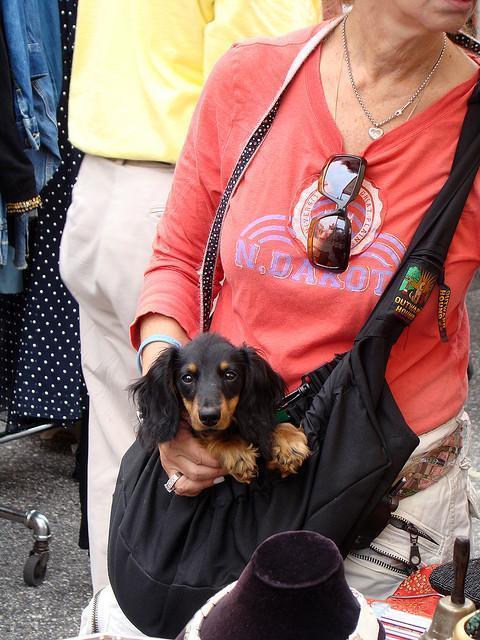How many people are there?
Give a very brief answer. 2. 